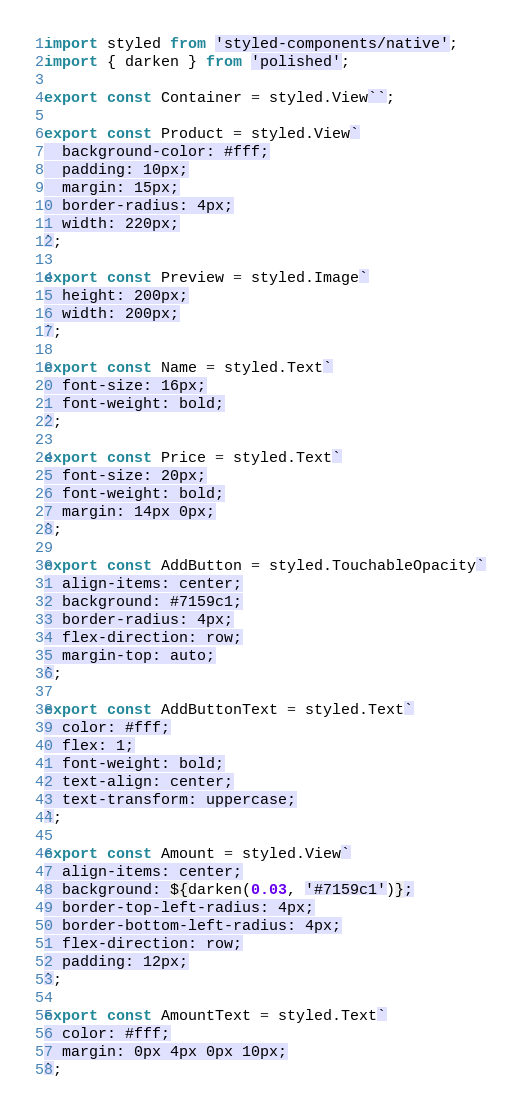Convert code to text. <code><loc_0><loc_0><loc_500><loc_500><_JavaScript_>import styled from 'styled-components/native';
import { darken } from 'polished';

export const Container = styled.View``;

export const Product = styled.View`
  background-color: #fff;
  padding: 10px;
  margin: 15px;
  border-radius: 4px;
  width: 220px;
`;

export const Preview = styled.Image`
  height: 200px;
  width: 200px;
`;

export const Name = styled.Text`
  font-size: 16px;
  font-weight: bold;
`;

export const Price = styled.Text`
  font-size: 20px;
  font-weight: bold;
  margin: 14px 0px;
`;

export const AddButton = styled.TouchableOpacity`
  align-items: center;
  background: #7159c1;
  border-radius: 4px;
  flex-direction: row;
  margin-top: auto;
`;

export const AddButtonText = styled.Text`
  color: #fff;
  flex: 1;
  font-weight: bold;
  text-align: center;
  text-transform: uppercase;
`;

export const Amount = styled.View`
  align-items: center;
  background: ${darken(0.03, '#7159c1')};
  border-top-left-radius: 4px;
  border-bottom-left-radius: 4px;
  flex-direction: row;
  padding: 12px;
`;

export const AmountText = styled.Text`
  color: #fff;
  margin: 0px 4px 0px 10px;
`;
</code> 